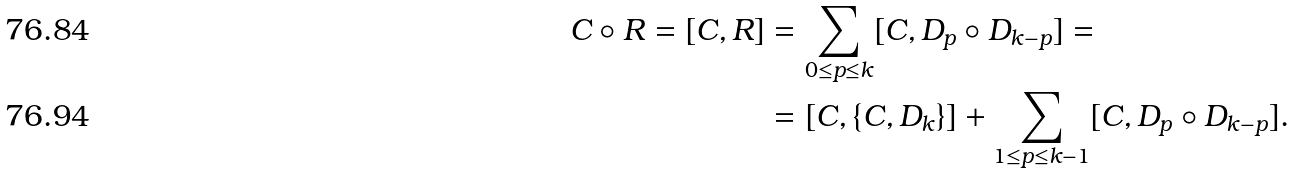Convert formula to latex. <formula><loc_0><loc_0><loc_500><loc_500>C \circ R = [ C , R ] & = \sum _ { 0 \leq p \leq k } [ C , D _ { p } \circ D _ { k - p } ] = \\ & = [ C , \{ C , D _ { k } \} ] + \sum _ { 1 \leq p \leq k - 1 } [ C , D _ { p } \circ D _ { k - p } ] .</formula> 